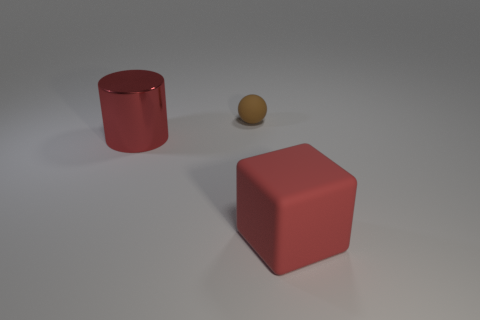Subtract 1 balls. How many balls are left? 0 Add 3 tiny brown spheres. How many objects exist? 6 Subtract all blocks. How many objects are left? 2 Add 1 small rubber things. How many small rubber things are left? 2 Add 2 large blocks. How many large blocks exist? 3 Subtract 1 red blocks. How many objects are left? 2 Subtract all cyan cylinders. Subtract all red balls. How many cylinders are left? 1 Subtract all big metal things. Subtract all large things. How many objects are left? 0 